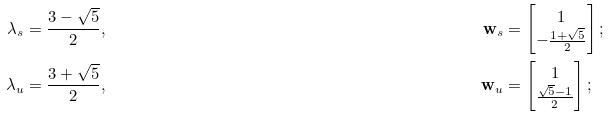Convert formula to latex. <formula><loc_0><loc_0><loc_500><loc_500>\lambda _ { s } & = \frac { 3 - \sqrt { 5 } } { 2 } , & { \mathbf w } _ { s } & = \begin{bmatrix} 1 \\ - \frac { 1 + \sqrt { 5 } } { 2 } \end{bmatrix} ; \\ \lambda _ { u } & = \frac { 3 + \sqrt { 5 } } { 2 } , & { \mathbf w } _ { u } & = \begin{bmatrix} 1 \\ \frac { \sqrt { 5 } - 1 } { 2 } \end{bmatrix} ;</formula> 